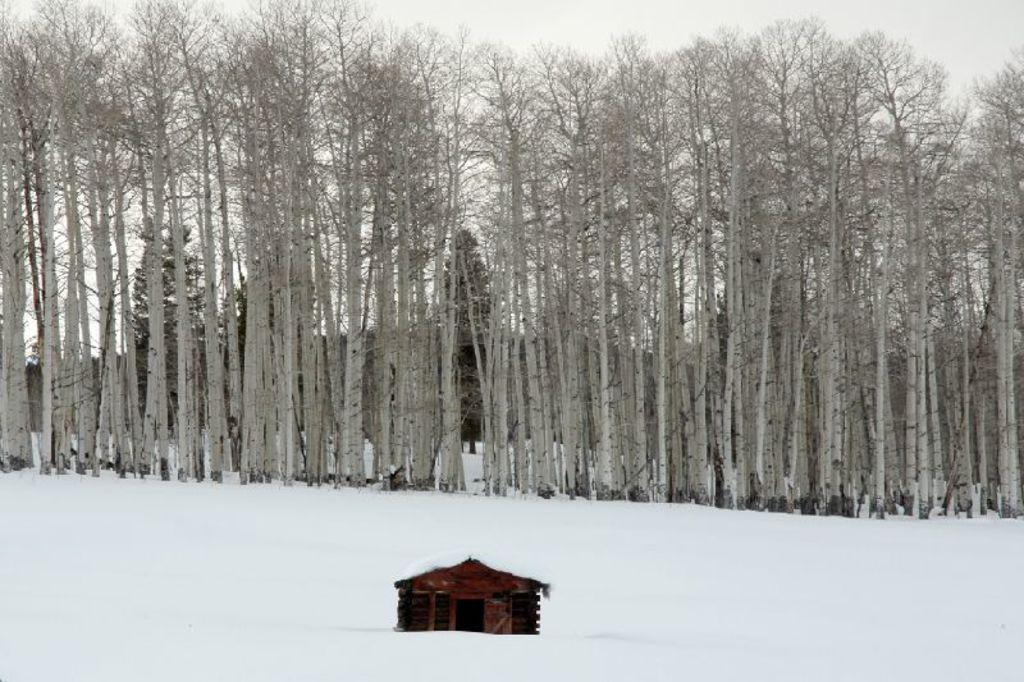What type of structure is visible in the image? There is a home in the image. What is the condition of the land surrounding the home? The land surrounding the home is covered in snow. What can be seen behind the home? There are many trees behind the home. What is visible above the home? The sky is visible above the home. What type of prose is being recited by the trees in the image? There is no indication in the image that the trees are reciting any prose. 